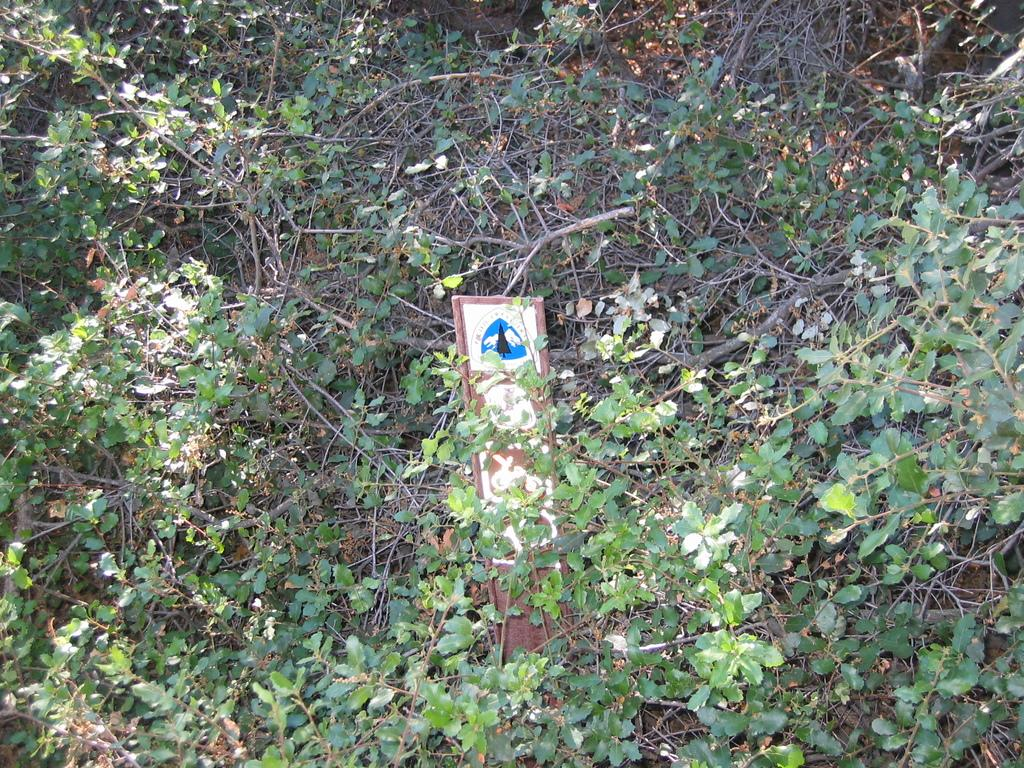What material is the board in the image made of? The wooden board in the image is made of wood. What else can be seen in the image besides the wooden board? There are plants in the image. How many horses are depicted in the image? There are no horses present in the image. What type of plot is being shown in the image? The image does not depict a plot; it features a wooden board and plants. 